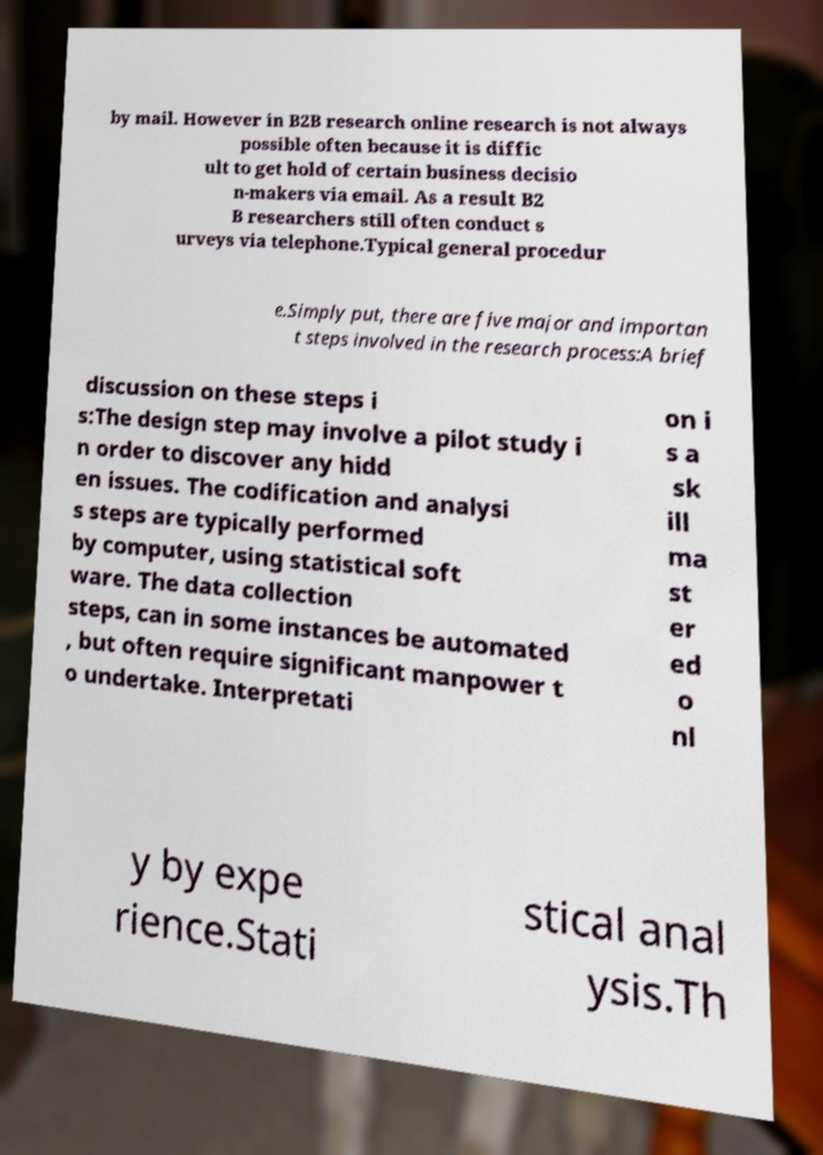What messages or text are displayed in this image? I need them in a readable, typed format. by mail. However in B2B research online research is not always possible often because it is diffic ult to get hold of certain business decisio n-makers via email. As a result B2 B researchers still often conduct s urveys via telephone.Typical general procedur e.Simply put, there are five major and importan t steps involved in the research process:A brief discussion on these steps i s:The design step may involve a pilot study i n order to discover any hidd en issues. The codification and analysi s steps are typically performed by computer, using statistical soft ware. The data collection steps, can in some instances be automated , but often require significant manpower t o undertake. Interpretati on i s a sk ill ma st er ed o nl y by expe rience.Stati stical anal ysis.Th 